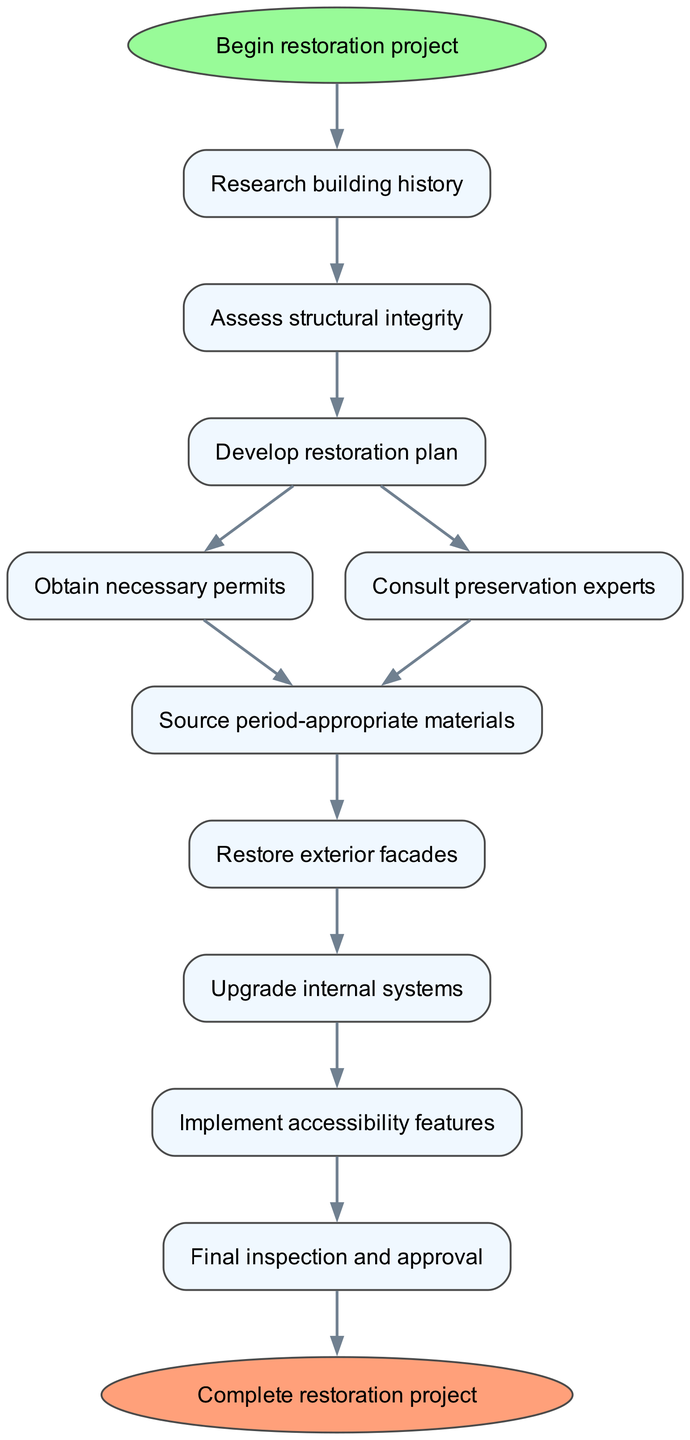What is the first step in the restoration process? According to the diagram, the first step after "Begin restoration project" is "Research building history". This is indicated as the next node after the start.
Answer: Research building history How many nodes are there in total in the diagram? The diagram contains a total of 11 nodes, including the start and end nodes. The nodes represent each step and state in the restoration process.
Answer: 11 Which step follows after "Develop restoration plan"? After "Develop restoration plan", there are two possible next steps: "Obtain necessary permits" and "Consult preservation experts". Both steps are listed as potential paths branching off from this node.
Answer: Obtain necessary permits, Consult preservation experts What is the last step of the restoration project? The last step of the restoration project is "Final inspection and approval", which leads to the end node labeled "Complete restoration project". This step is the final quality check before completing the entire project.
Answer: Final inspection and approval What are the two steps that can occur after "Develop restoration plan"? After "Develop restoration plan", the two steps that can occur are "Obtain necessary permits" and "Consult preservation experts". This branching indicates that both steps are needed for the progression of the project.
Answer: Obtain necessary permits, Consult preservation experts In which step is period-appropriate materials sourced? The sourcing of period-appropriate materials occurs in the "Source period-appropriate materials" step, which follows after obtaining permits and consulting with experts. It is crucial for maintaining the building's original character.
Answer: Source period-appropriate materials How does one proceed if the structural integrity is assessed satisfactorily? If the structural integrity is assessed satisfactorily, one proceeds to the "Develop restoration plan" step, as indicated by the direct connection from the "Assess structural integrity" node to the next step.
Answer: Develop restoration plan What is the significance of "Implement accessibility features"? "Implement accessibility features" is significant as it represents a crucial step in modernizing the historic building, ensuring it meets current building codes and accessibility standards for all visitors.
Answer: Modernizing and ensuring compliance What is the relationship between “Final inspection and approval” and “Complete restoration project”? The relationship is that "Final inspection and approval" is the last step before reaching the ultimate outcome, which is labeled "Complete restoration project". It signifies that the project can only be considered complete after this inspection.
Answer: Final step before completion 